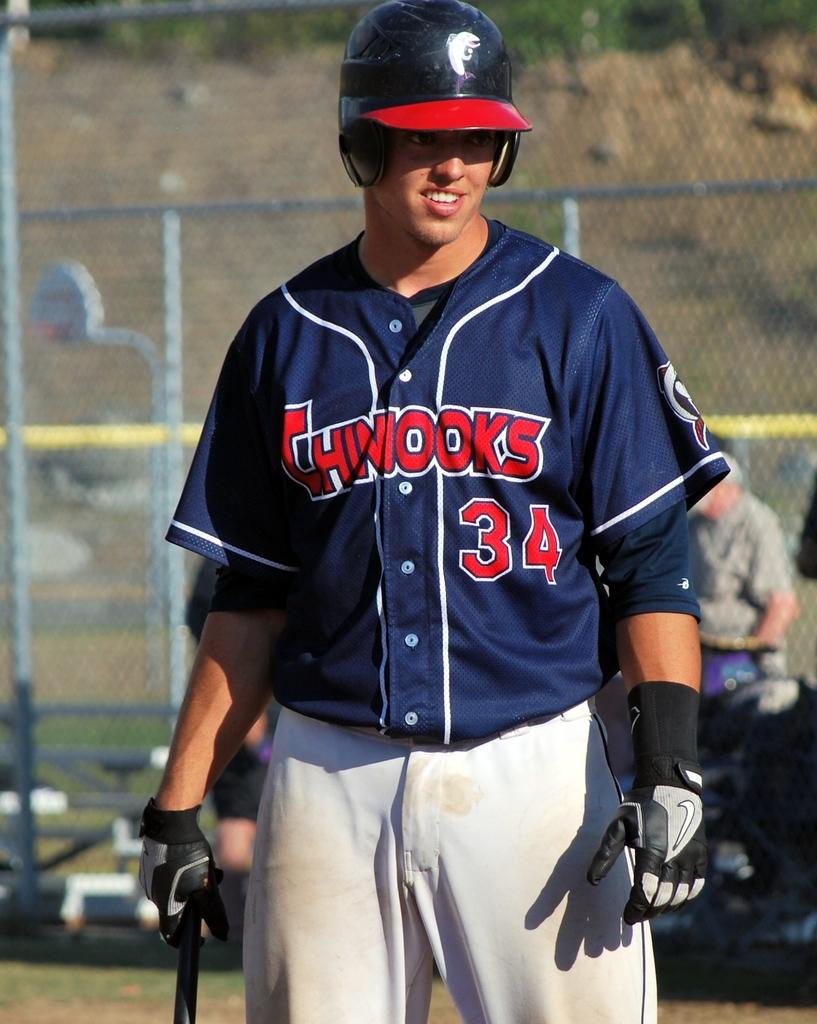What's the name of the team on the shirt?
Offer a terse response. Chinooks. What is the number on the player's shirt?
Make the answer very short. 34. 